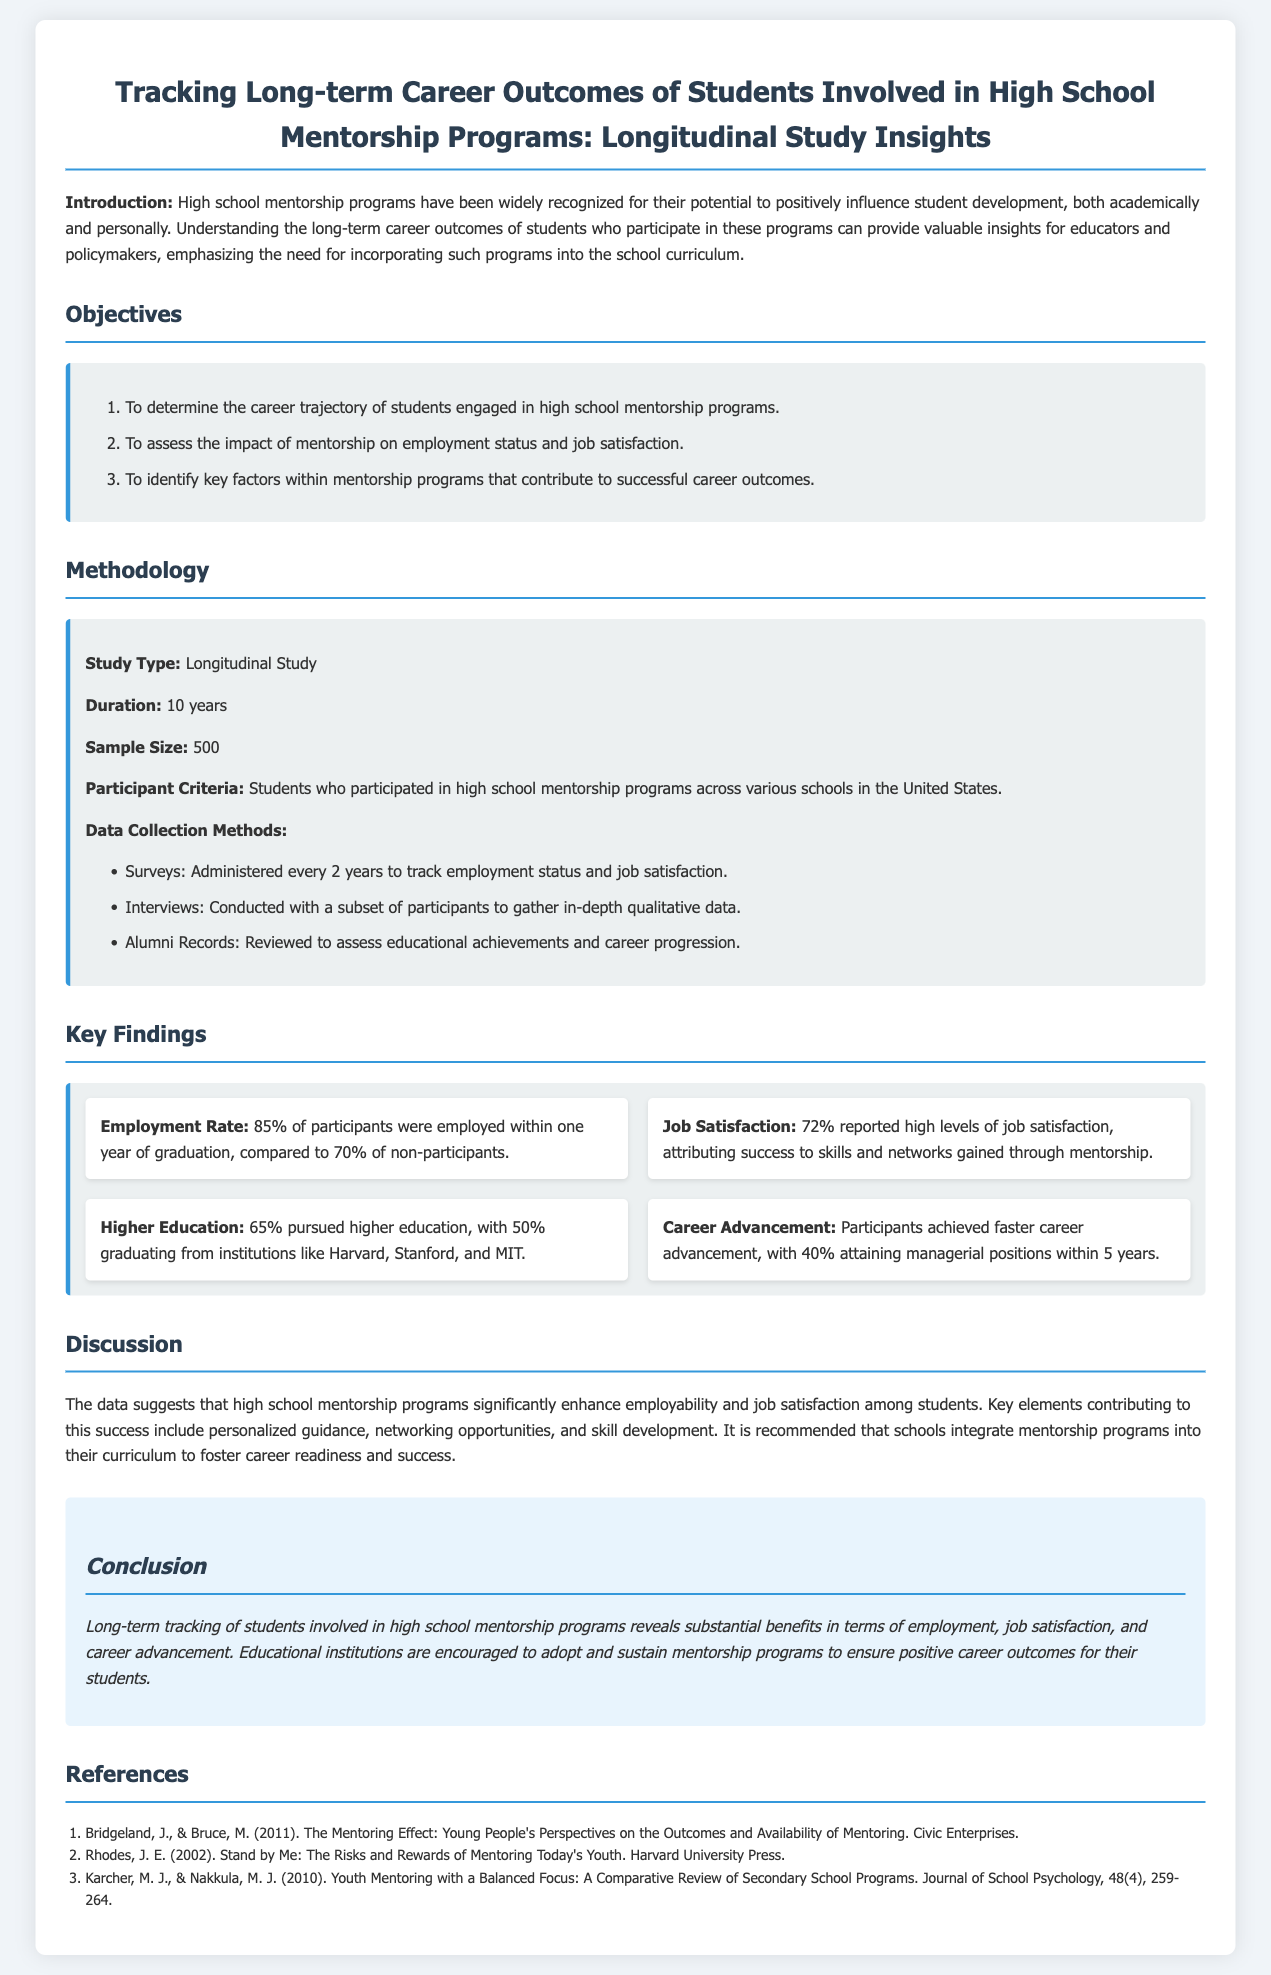What is the duration of the study? The duration of the study is specified as the length of time data was collected, which is 10 years.
Answer: 10 years What percentage of participants were employed within one year of graduation? The document states that 85% of participants were employed within one year of graduation.
Answer: 85% What is the reported job satisfaction percentage among participants? The report indicates that 72% reported high levels of job satisfaction.
Answer: 72% What is one key factor contributing to successful career outcomes mentioned in the findings? The key factors include personalized guidance, networking opportunities, and skill development as mentioned in the discussion section.
Answer: Personalized guidance How many students participated in the study? The sample size of the study is given as the total number of participants which is 500.
Answer: 500 What percentage of participants pursued higher education? The document mentions that 65% pursued higher education after their high school experience.
Answer: 65% What type of study is conducted in this report? The study type is described as a longitudinal study which focuses on tracking over time.
Answer: Longitudinal Study What is one recommendation made in the conclusion of the report? The conclusion suggests that educational institutions are encouraged to adopt and sustain mentorship programs.
Answer: Adopt and sustain mentorship programs 